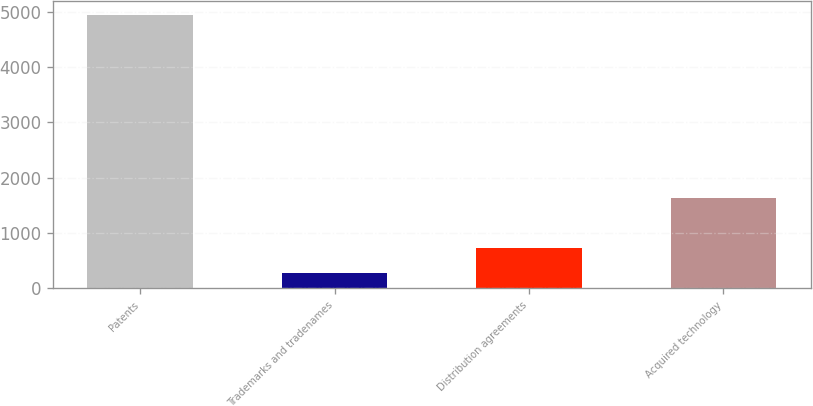Convert chart. <chart><loc_0><loc_0><loc_500><loc_500><bar_chart><fcel>Patents<fcel>Trademarks and tradenames<fcel>Distribution agreements<fcel>Acquired technology<nl><fcel>4944<fcel>269<fcel>736.5<fcel>1640<nl></chart> 